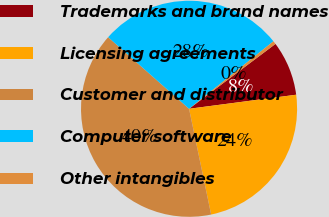<chart> <loc_0><loc_0><loc_500><loc_500><pie_chart><fcel>Trademarks and brand names<fcel>Licensing agreements<fcel>Customer and distributor<fcel>Computer software<fcel>Other intangibles<nl><fcel>8.17%<fcel>23.8%<fcel>39.8%<fcel>27.73%<fcel>0.49%<nl></chart> 